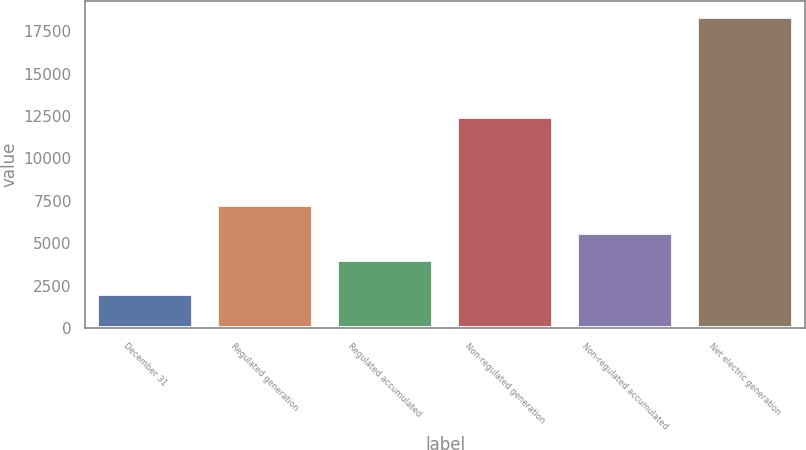Convert chart. <chart><loc_0><loc_0><loc_500><loc_500><bar_chart><fcel>December 31<fcel>Regulated generation<fcel>Regulated accumulated<fcel>Non-regulated generation<fcel>Non-regulated accumulated<fcel>Net electric generation<nl><fcel>2015<fcel>7249.6<fcel>3984<fcel>12421.8<fcel>5616.8<fcel>18343<nl></chart> 